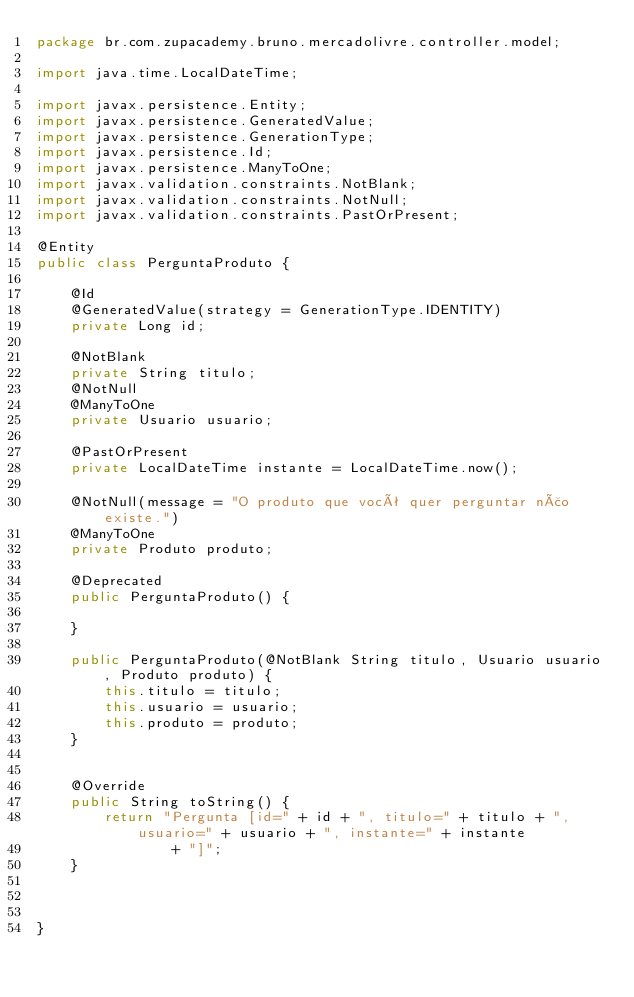<code> <loc_0><loc_0><loc_500><loc_500><_Java_>package br.com.zupacademy.bruno.mercadolivre.controller.model;

import java.time.LocalDateTime;

import javax.persistence.Entity;
import javax.persistence.GeneratedValue;
import javax.persistence.GenerationType;
import javax.persistence.Id;
import javax.persistence.ManyToOne;
import javax.validation.constraints.NotBlank;
import javax.validation.constraints.NotNull;
import javax.validation.constraints.PastOrPresent;

@Entity
public class PerguntaProduto {

	@Id
	@GeneratedValue(strategy = GenerationType.IDENTITY)
	private Long id;
	
	@NotBlank
	private String titulo;
	@NotNull
	@ManyToOne
	private Usuario usuario;
	
	@PastOrPresent
	private LocalDateTime instante = LocalDateTime.now();

	@NotNull(message = "O produto que você quer perguntar não existe.")
	@ManyToOne
	private Produto produto;

	@Deprecated
	public PerguntaProduto() {

	}

	public PerguntaProduto(@NotBlank String titulo, Usuario usuario, Produto produto) {
		this.titulo = titulo;
		this.usuario = usuario;
		this.produto = produto;
	}
	

	@Override
	public String toString() {
		return "Pergunta [id=" + id + ", titulo=" + titulo + ", usuario=" + usuario + ", instante=" + instante
				+ "]";
	}

	

}
</code> 